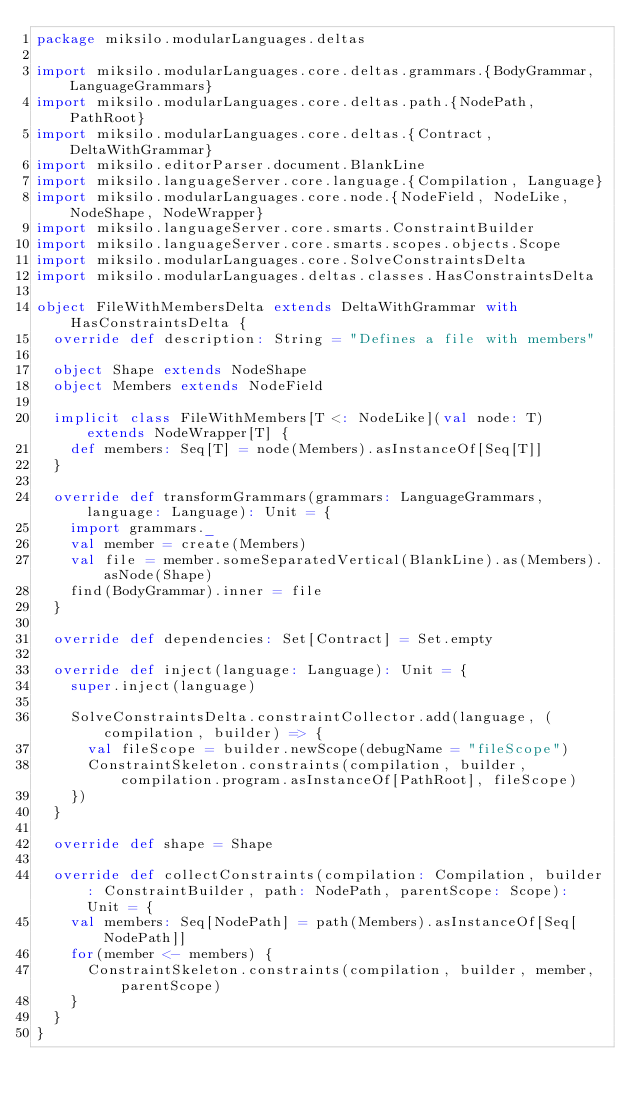<code> <loc_0><loc_0><loc_500><loc_500><_Scala_>package miksilo.modularLanguages.deltas

import miksilo.modularLanguages.core.deltas.grammars.{BodyGrammar, LanguageGrammars}
import miksilo.modularLanguages.core.deltas.path.{NodePath, PathRoot}
import miksilo.modularLanguages.core.deltas.{Contract, DeltaWithGrammar}
import miksilo.editorParser.document.BlankLine
import miksilo.languageServer.core.language.{Compilation, Language}
import miksilo.modularLanguages.core.node.{NodeField, NodeLike, NodeShape, NodeWrapper}
import miksilo.languageServer.core.smarts.ConstraintBuilder
import miksilo.languageServer.core.smarts.scopes.objects.Scope
import miksilo.modularLanguages.core.SolveConstraintsDelta
import miksilo.modularLanguages.deltas.classes.HasConstraintsDelta

object FileWithMembersDelta extends DeltaWithGrammar with HasConstraintsDelta {
  override def description: String = "Defines a file with members"

  object Shape extends NodeShape
  object Members extends NodeField

  implicit class FileWithMembers[T <: NodeLike](val node: T) extends NodeWrapper[T] {
    def members: Seq[T] = node(Members).asInstanceOf[Seq[T]]
  }

  override def transformGrammars(grammars: LanguageGrammars, language: Language): Unit = {
    import grammars._
    val member = create(Members)
    val file = member.someSeparatedVertical(BlankLine).as(Members).asNode(Shape)
    find(BodyGrammar).inner = file
  }

  override def dependencies: Set[Contract] = Set.empty

  override def inject(language: Language): Unit = {
    super.inject(language)

    SolveConstraintsDelta.constraintCollector.add(language, (compilation, builder) => {
      val fileScope = builder.newScope(debugName = "fileScope")
      ConstraintSkeleton.constraints(compilation, builder, compilation.program.asInstanceOf[PathRoot], fileScope)
    })
  }

  override def shape = Shape

  override def collectConstraints(compilation: Compilation, builder: ConstraintBuilder, path: NodePath, parentScope: Scope): Unit = {
    val members: Seq[NodePath] = path(Members).asInstanceOf[Seq[NodePath]]
    for(member <- members) {
      ConstraintSkeleton.constraints(compilation, builder, member, parentScope)
    }
  }
}
</code> 